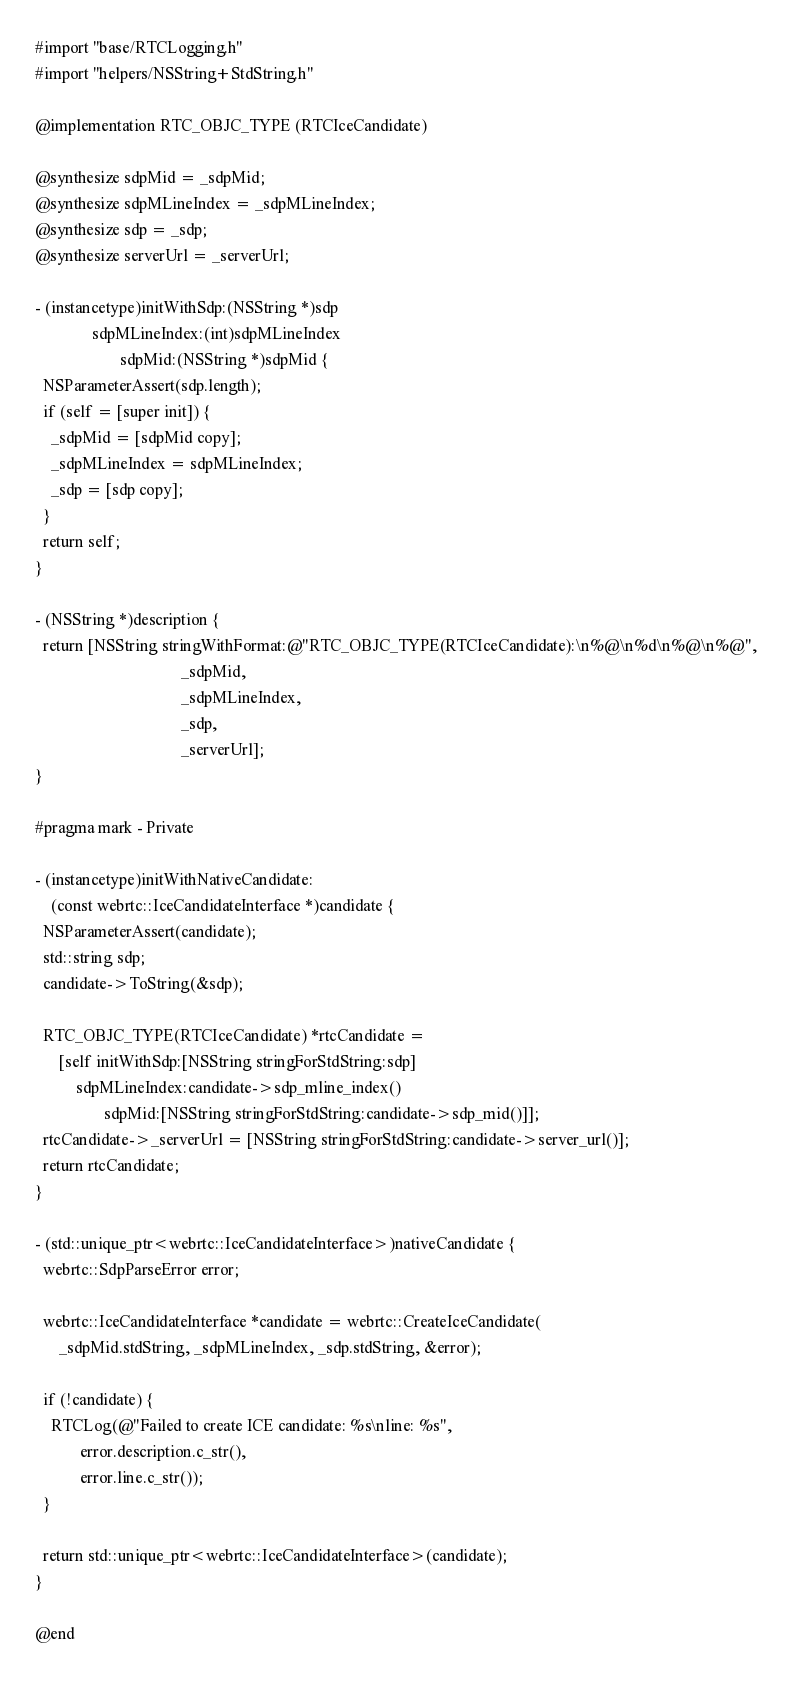Convert code to text. <code><loc_0><loc_0><loc_500><loc_500><_ObjectiveC_>
#import "base/RTCLogging.h"
#import "helpers/NSString+StdString.h"

@implementation RTC_OBJC_TYPE (RTCIceCandidate)

@synthesize sdpMid = _sdpMid;
@synthesize sdpMLineIndex = _sdpMLineIndex;
@synthesize sdp = _sdp;
@synthesize serverUrl = _serverUrl;

- (instancetype)initWithSdp:(NSString *)sdp
              sdpMLineIndex:(int)sdpMLineIndex
                     sdpMid:(NSString *)sdpMid {
  NSParameterAssert(sdp.length);
  if (self = [super init]) {
    _sdpMid = [sdpMid copy];
    _sdpMLineIndex = sdpMLineIndex;
    _sdp = [sdp copy];
  }
  return self;
}

- (NSString *)description {
  return [NSString stringWithFormat:@"RTC_OBJC_TYPE(RTCIceCandidate):\n%@\n%d\n%@\n%@",
                                    _sdpMid,
                                    _sdpMLineIndex,
                                    _sdp,
                                    _serverUrl];
}

#pragma mark - Private

- (instancetype)initWithNativeCandidate:
    (const webrtc::IceCandidateInterface *)candidate {
  NSParameterAssert(candidate);
  std::string sdp;
  candidate->ToString(&sdp);

  RTC_OBJC_TYPE(RTCIceCandidate) *rtcCandidate =
      [self initWithSdp:[NSString stringForStdString:sdp]
          sdpMLineIndex:candidate->sdp_mline_index()
                 sdpMid:[NSString stringForStdString:candidate->sdp_mid()]];
  rtcCandidate->_serverUrl = [NSString stringForStdString:candidate->server_url()];
  return rtcCandidate;
}

- (std::unique_ptr<webrtc::IceCandidateInterface>)nativeCandidate {
  webrtc::SdpParseError error;

  webrtc::IceCandidateInterface *candidate = webrtc::CreateIceCandidate(
      _sdpMid.stdString, _sdpMLineIndex, _sdp.stdString, &error);

  if (!candidate) {
    RTCLog(@"Failed to create ICE candidate: %s\nline: %s",
           error.description.c_str(),
           error.line.c_str());
  }

  return std::unique_ptr<webrtc::IceCandidateInterface>(candidate);
}

@end
</code> 